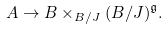<formula> <loc_0><loc_0><loc_500><loc_500>A \rightarrow B \times _ { B / J } ( B / J ) ^ { \mathfrak { g } } .</formula> 